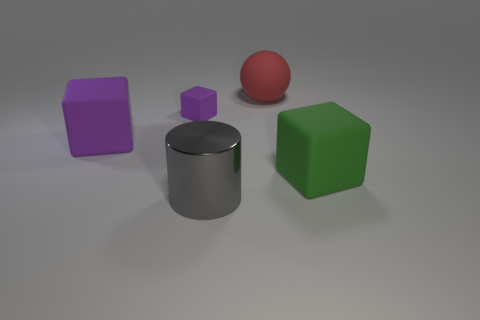Subtract 1 blocks. How many blocks are left? 2 Add 5 large gray cylinders. How many objects exist? 10 Subtract all spheres. How many objects are left? 4 Subtract 0 cyan cylinders. How many objects are left? 5 Subtract all big purple rubber cubes. Subtract all cylinders. How many objects are left? 3 Add 4 gray metal cylinders. How many gray metal cylinders are left? 5 Add 5 tiny blue balls. How many tiny blue balls exist? 5 